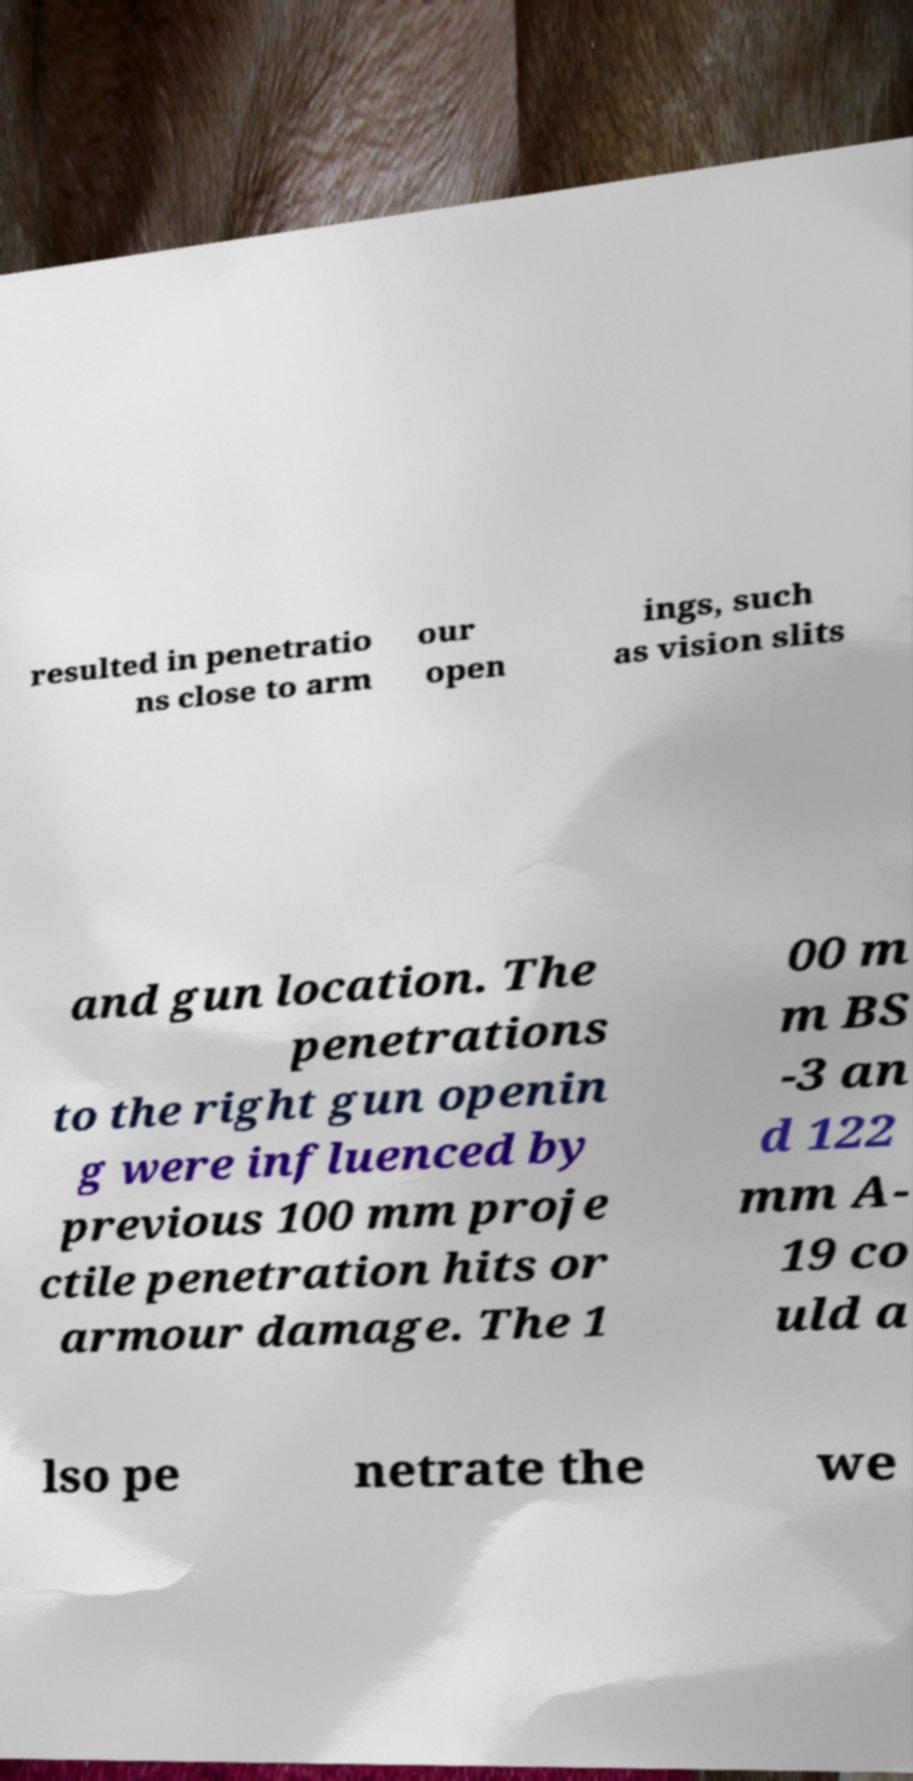Please identify and transcribe the text found in this image. resulted in penetratio ns close to arm our open ings, such as vision slits and gun location. The penetrations to the right gun openin g were influenced by previous 100 mm proje ctile penetration hits or armour damage. The 1 00 m m BS -3 an d 122 mm A- 19 co uld a lso pe netrate the we 